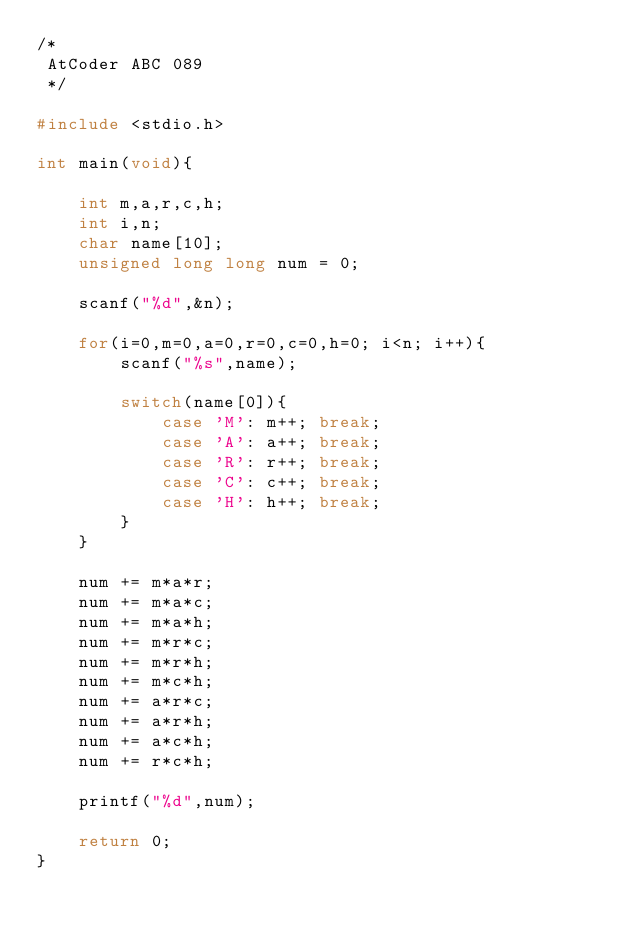<code> <loc_0><loc_0><loc_500><loc_500><_C_>/*
 AtCoder ABC 089
 */
 
#include <stdio.h>

int main(void){
	
	int m,a,r,c,h;
	int i,n;
	char name[10];
	unsigned long long num = 0;
	
	scanf("%d",&n);
	
	for(i=0,m=0,a=0,r=0,c=0,h=0; i<n; i++){
		scanf("%s",name);
		
		switch(name[0]){
			case 'M': m++; break;
			case 'A': a++; break;
			case 'R': r++; break;
			case 'C': c++; break;
			case 'H': h++; break;
		}
	}
	
	num += m*a*r;
	num += m*a*c;
	num += m*a*h;
	num += m*r*c;
	num += m*r*h;
	num += m*c*h;
	num += a*r*c;
	num += a*r*h;
	num += a*c*h;
	num += r*c*h;
	
	printf("%d",num);
	
	return 0;
}</code> 